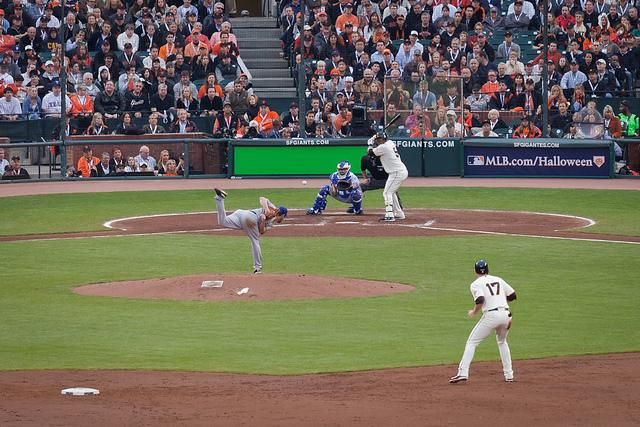What is the man on one leg doing? Please explain your reasoning. pitching. The man is trying to get the ball. 